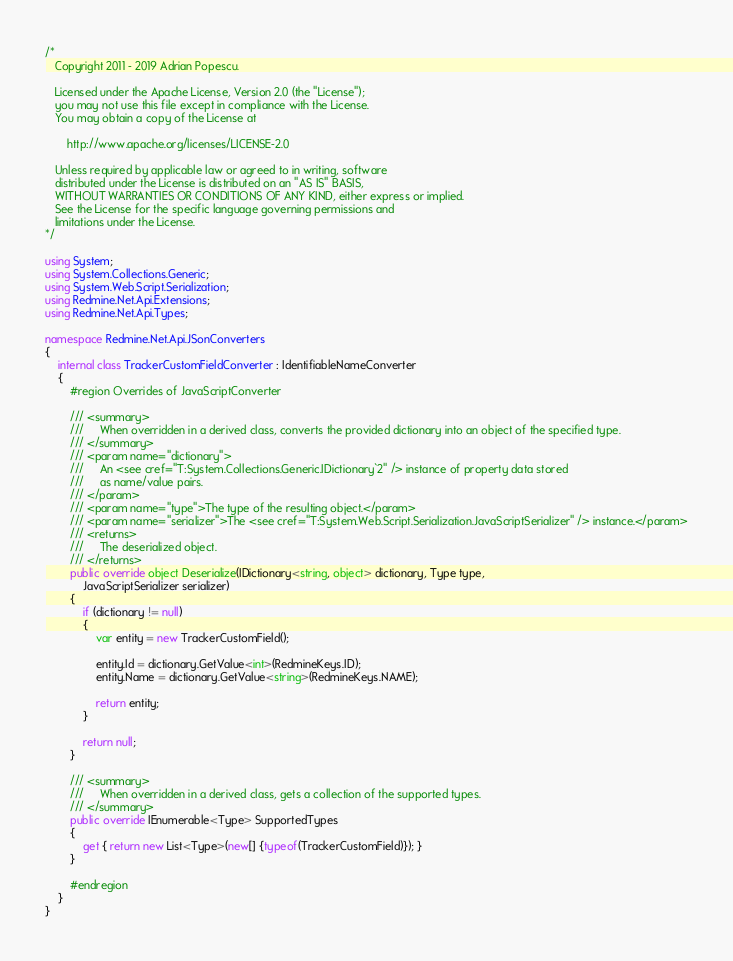<code> <loc_0><loc_0><loc_500><loc_500><_C#_>/*
   Copyright 2011 - 2019 Adrian Popescu.

   Licensed under the Apache License, Version 2.0 (the "License");
   you may not use this file except in compliance with the License.
   You may obtain a copy of the License at

       http://www.apache.org/licenses/LICENSE-2.0

   Unless required by applicable law or agreed to in writing, software
   distributed under the License is distributed on an "AS IS" BASIS,
   WITHOUT WARRANTIES OR CONDITIONS OF ANY KIND, either express or implied.
   See the License for the specific language governing permissions and
   limitations under the License.
*/

using System;
using System.Collections.Generic;
using System.Web.Script.Serialization;
using Redmine.Net.Api.Extensions;
using Redmine.Net.Api.Types;

namespace Redmine.Net.Api.JSonConverters
{
    internal class TrackerCustomFieldConverter : IdentifiableNameConverter
    {
        #region Overrides of JavaScriptConverter

        /// <summary>
        ///     When overridden in a derived class, converts the provided dictionary into an object of the specified type.
        /// </summary>
        /// <param name="dictionary">
        ///     An <see cref="T:System.Collections.Generic.IDictionary`2" /> instance of property data stored
        ///     as name/value pairs.
        /// </param>
        /// <param name="type">The type of the resulting object.</param>
        /// <param name="serializer">The <see cref="T:System.Web.Script.Serialization.JavaScriptSerializer" /> instance.</param>
        /// <returns>
        ///     The deserialized object.
        /// </returns>
        public override object Deserialize(IDictionary<string, object> dictionary, Type type,
            JavaScriptSerializer serializer)
        {
            if (dictionary != null)
            {
                var entity = new TrackerCustomField();

                entity.Id = dictionary.GetValue<int>(RedmineKeys.ID);
                entity.Name = dictionary.GetValue<string>(RedmineKeys.NAME);

                return entity;
            }

            return null;
        }

        /// <summary>
        ///     When overridden in a derived class, gets a collection of the supported types.
        /// </summary>
        public override IEnumerable<Type> SupportedTypes
        {
            get { return new List<Type>(new[] {typeof(TrackerCustomField)}); }
        }

        #endregion
    }
}</code> 